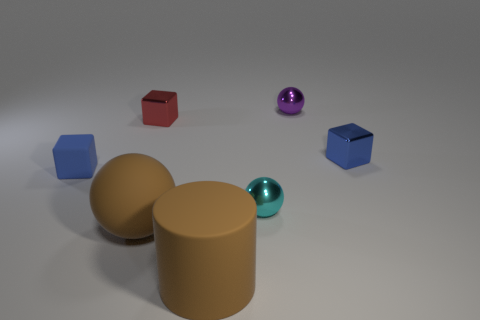Subtract all small matte cubes. How many cubes are left? 2 Subtract all red blocks. How many blocks are left? 2 Subtract 2 blocks. How many blocks are left? 1 Subtract all red cylinders. Subtract all green blocks. How many cylinders are left? 1 Subtract all cubes. How many objects are left? 4 Subtract all brown cubes. How many cyan balls are left? 1 Subtract all tiny purple spheres. Subtract all tiny metallic objects. How many objects are left? 2 Add 3 brown rubber objects. How many brown rubber objects are left? 5 Add 1 cyan metal objects. How many cyan metal objects exist? 2 Add 1 blue cubes. How many objects exist? 8 